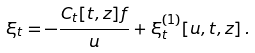Convert formula to latex. <formula><loc_0><loc_0><loc_500><loc_500>\xi _ { t } = - { \frac { C _ { t } [ t , z ] f } { u } } + \xi _ { t } ^ { ( 1 ) } [ u , t , z ] \, .</formula> 